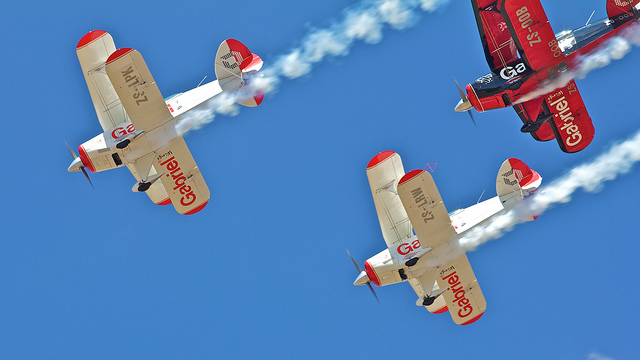What type of event could these airplanes be participating in? These airplanes are likely participating in an airshow, which is an event where pilots perform aerial stunts and maneuvers for an audience. The synchronized flying and smoke trails are characteristic of such displays. Do these types of airplanes have a specific name? Airplanes like these, with two main wings stacked one above the other, are called biplanes. They were prevalent during the early years of aviation and are often showcased at events celebrating flight history. 